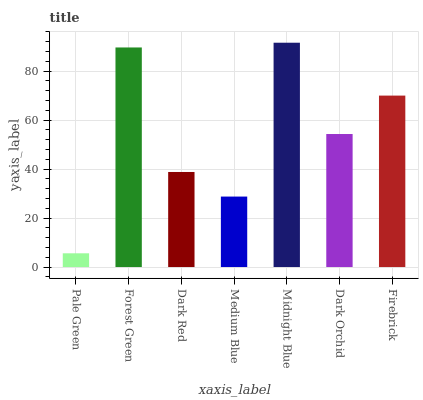Is Pale Green the minimum?
Answer yes or no. Yes. Is Midnight Blue the maximum?
Answer yes or no. Yes. Is Forest Green the minimum?
Answer yes or no. No. Is Forest Green the maximum?
Answer yes or no. No. Is Forest Green greater than Pale Green?
Answer yes or no. Yes. Is Pale Green less than Forest Green?
Answer yes or no. Yes. Is Pale Green greater than Forest Green?
Answer yes or no. No. Is Forest Green less than Pale Green?
Answer yes or no. No. Is Dark Orchid the high median?
Answer yes or no. Yes. Is Dark Orchid the low median?
Answer yes or no. Yes. Is Dark Red the high median?
Answer yes or no. No. Is Firebrick the low median?
Answer yes or no. No. 